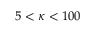<formula> <loc_0><loc_0><loc_500><loc_500>5 < \kappa < 1 0 0</formula> 